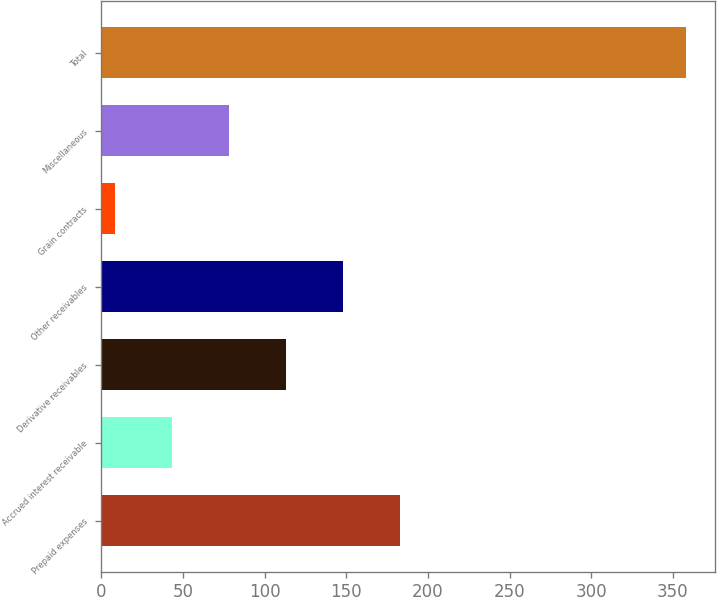Convert chart to OTSL. <chart><loc_0><loc_0><loc_500><loc_500><bar_chart><fcel>Prepaid expenses<fcel>Accrued interest receivable<fcel>Derivative receivables<fcel>Other receivables<fcel>Grain contracts<fcel>Miscellaneous<fcel>Total<nl><fcel>183.2<fcel>43.28<fcel>113.24<fcel>148.22<fcel>8.3<fcel>78.26<fcel>358.1<nl></chart> 